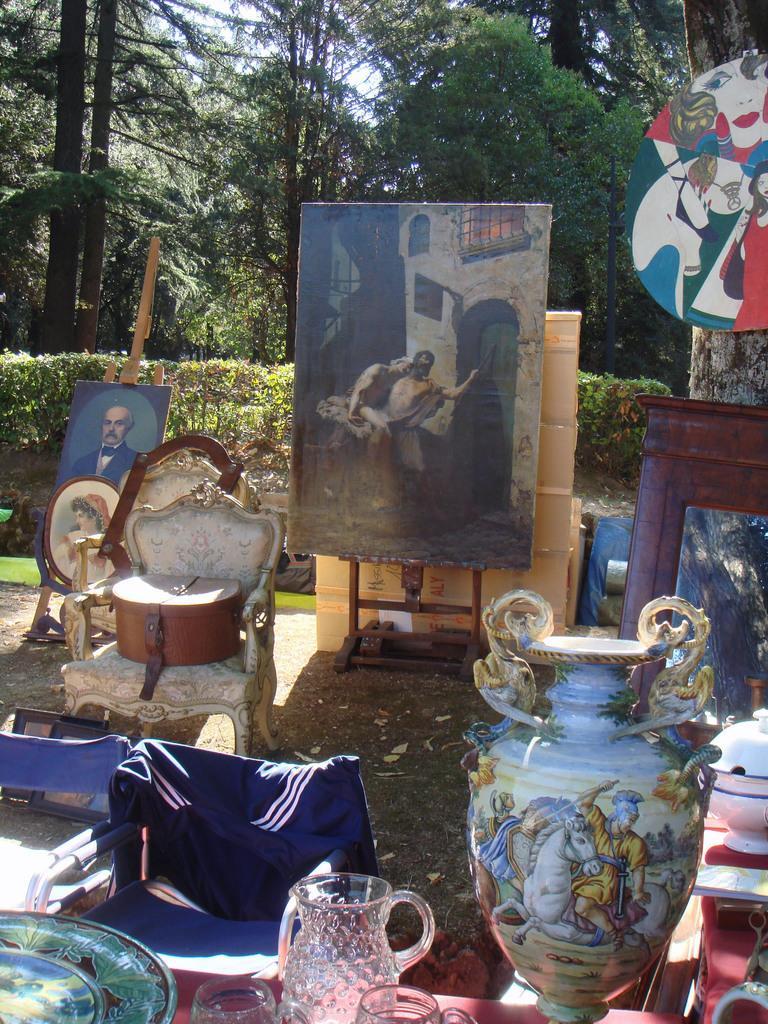Describe this image in one or two sentences. At the bottom of the image there is table with glasses, jar, plate and flower vase on it. There is a chair. In the background of the image there are paintings on the board. There is a chair with some object on it. In the background of the image there are trees and plants. 